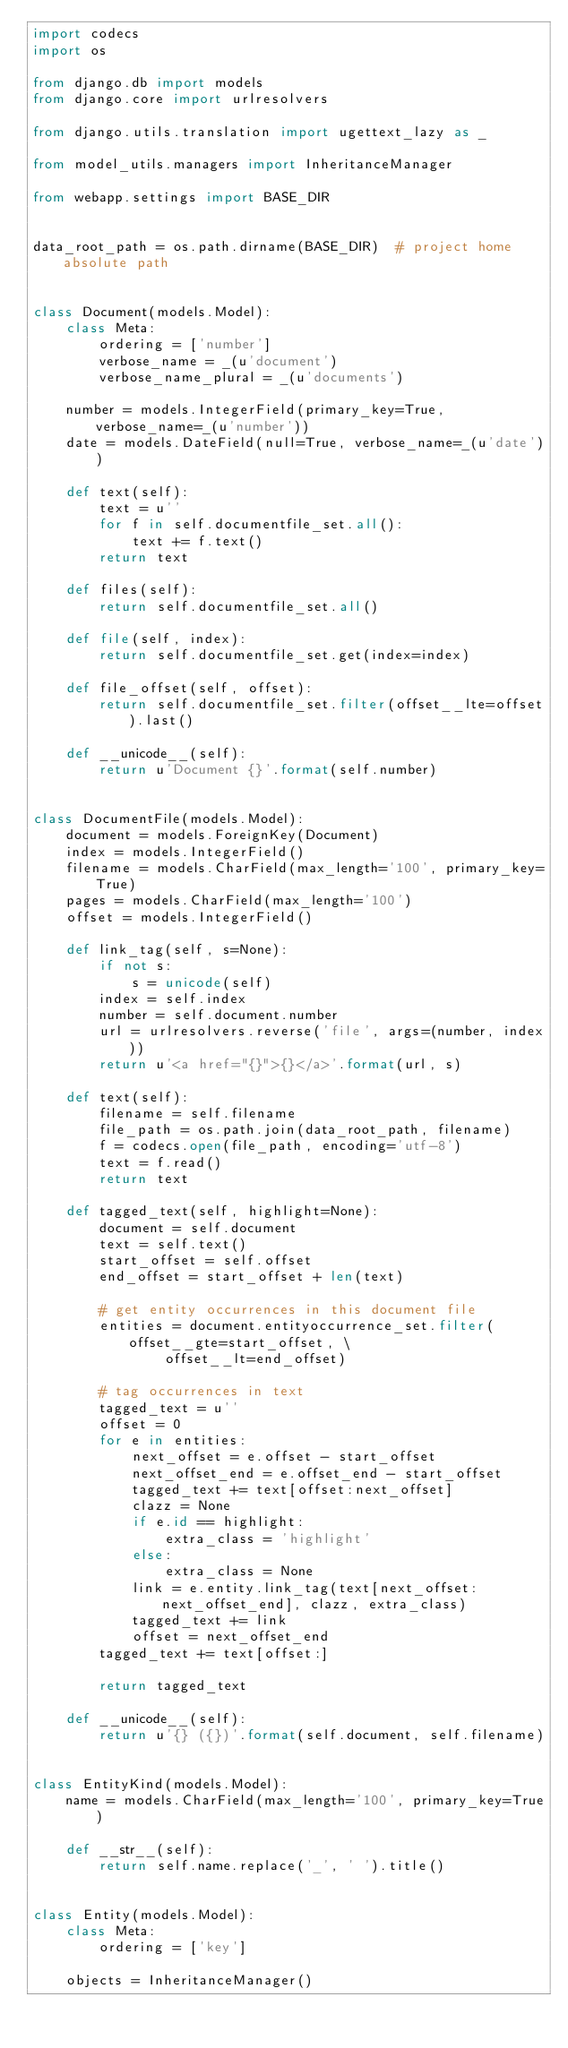<code> <loc_0><loc_0><loc_500><loc_500><_Python_>import codecs
import os

from django.db import models
from django.core import urlresolvers

from django.utils.translation import ugettext_lazy as _

from model_utils.managers import InheritanceManager

from webapp.settings import BASE_DIR


data_root_path = os.path.dirname(BASE_DIR)  # project home absolute path


class Document(models.Model):
    class Meta:
        ordering = ['number']
        verbose_name = _(u'document')
        verbose_name_plural = _(u'documents')

    number = models.IntegerField(primary_key=True, verbose_name=_(u'number'))
    date = models.DateField(null=True, verbose_name=_(u'date'))

    def text(self):
        text = u''
        for f in self.documentfile_set.all():
            text += f.text()
        return text

    def files(self):
        return self.documentfile_set.all()

    def file(self, index):
        return self.documentfile_set.get(index=index)

    def file_offset(self, offset):
        return self.documentfile_set.filter(offset__lte=offset).last()

    def __unicode__(self):
        return u'Document {}'.format(self.number)


class DocumentFile(models.Model):
    document = models.ForeignKey(Document)
    index = models.IntegerField()
    filename = models.CharField(max_length='100', primary_key=True)
    pages = models.CharField(max_length='100')
    offset = models.IntegerField()

    def link_tag(self, s=None):
        if not s:
            s = unicode(self)
        index = self.index
        number = self.document.number
        url = urlresolvers.reverse('file', args=(number, index))
        return u'<a href="{}">{}</a>'.format(url, s)

    def text(self):
        filename = self.filename
        file_path = os.path.join(data_root_path, filename)
        f = codecs.open(file_path, encoding='utf-8')
        text = f.read()
        return text

    def tagged_text(self, highlight=None):
        document = self.document
        text = self.text()
        start_offset = self.offset
        end_offset = start_offset + len(text)

        # get entity occurrences in this document file
        entities = document.entityoccurrence_set.filter(offset__gte=start_offset, \
                offset__lt=end_offset)

        # tag occurrences in text
        tagged_text = u''
        offset = 0
        for e in entities:
            next_offset = e.offset - start_offset
            next_offset_end = e.offset_end - start_offset
            tagged_text += text[offset:next_offset]
            clazz = None
            if e.id == highlight:
                extra_class = 'highlight'
            else:
                extra_class = None
            link = e.entity.link_tag(text[next_offset:next_offset_end], clazz, extra_class)
            tagged_text += link
            offset = next_offset_end
        tagged_text += text[offset:]

        return tagged_text

    def __unicode__(self):
        return u'{} ({})'.format(self.document, self.filename)


class EntityKind(models.Model):
    name = models.CharField(max_length='100', primary_key=True)

    def __str__(self):
        return self.name.replace('_', ' ').title()


class Entity(models.Model):
    class Meta:
        ordering = ['key']

    objects = InheritanceManager()</code> 